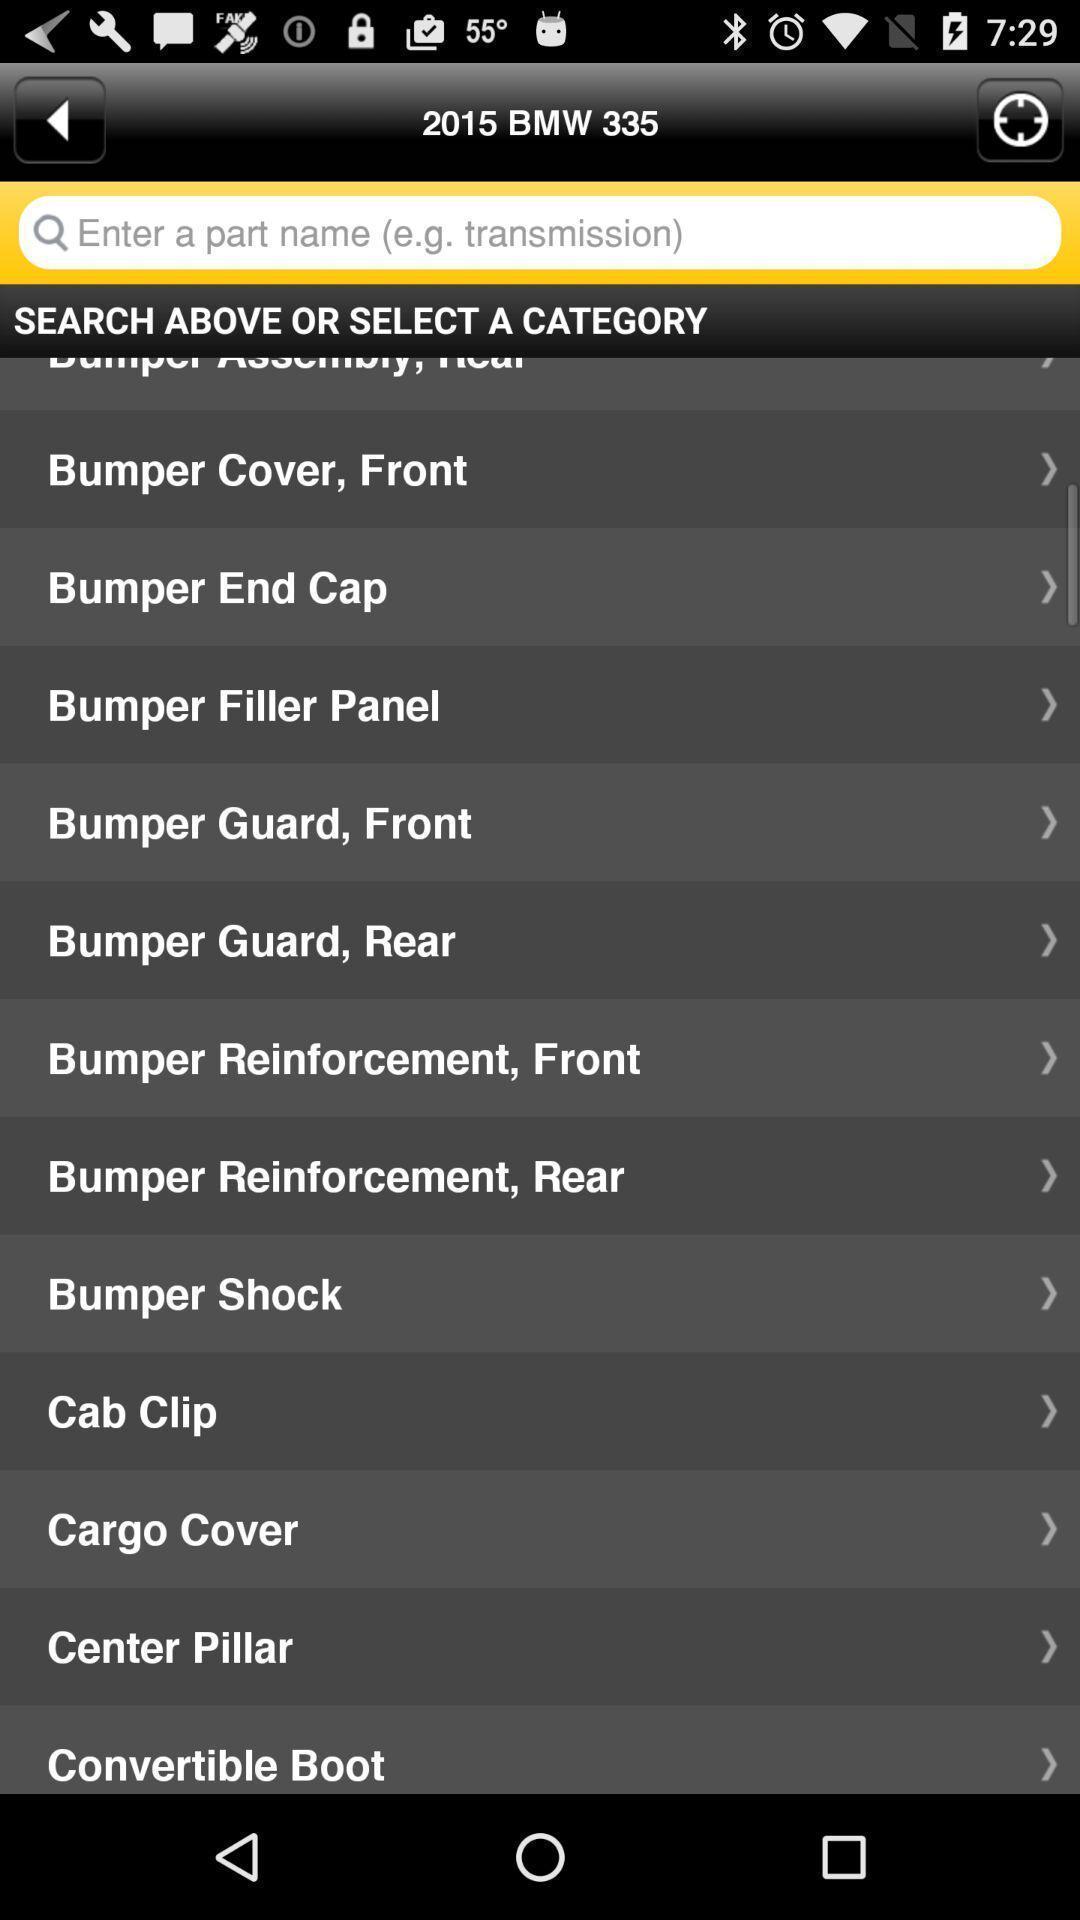Summarize the information in this screenshot. Search bar to select the category. 